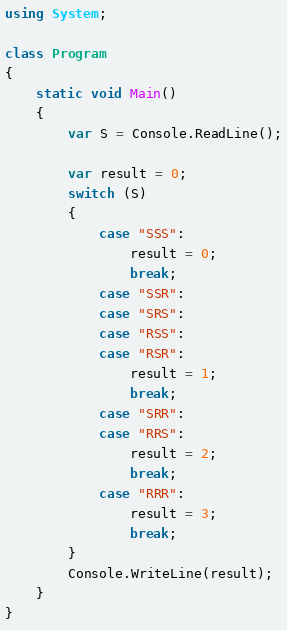<code> <loc_0><loc_0><loc_500><loc_500><_C#_>using System;

class Program
{
    static void Main()
    {
        var S = Console.ReadLine();

        var result = 0;
        switch (S)
        {
            case "SSS":
                result = 0;
                break;
            case "SSR":
            case "SRS":
            case "RSS":
            case "RSR":
                result = 1;
                break;
            case "SRR":
            case "RRS":
                result = 2;
                break;
            case "RRR":
                result = 3;
                break;
        }
        Console.WriteLine(result);
    }
}
</code> 